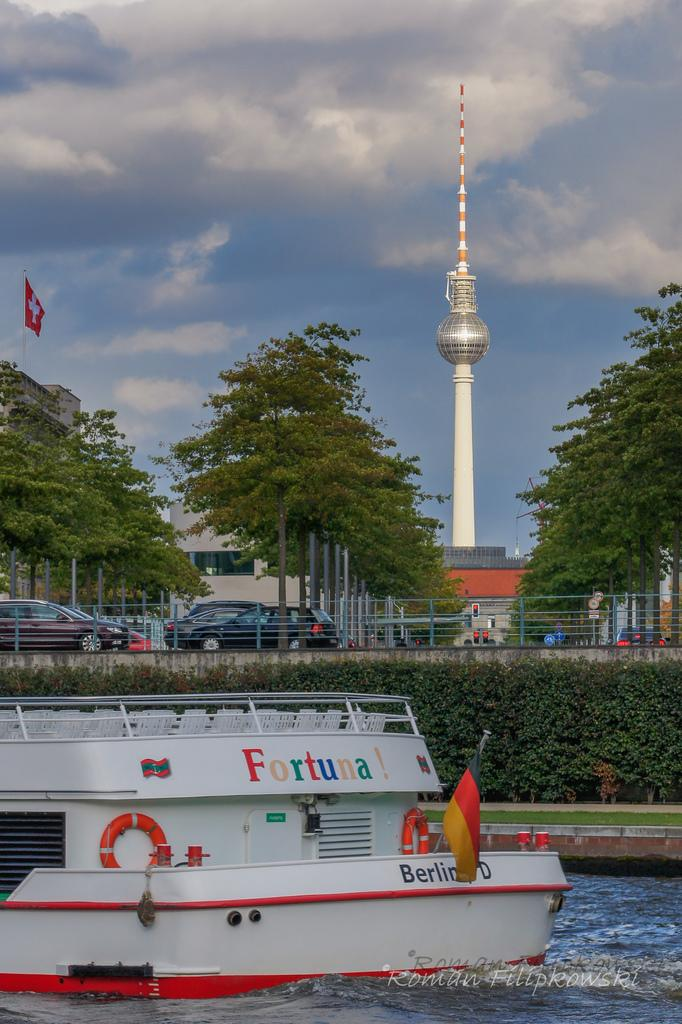Provide a one-sentence caption for the provided image. A boat with the name Fortuna! writtne in rainbow colors. 